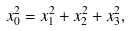<formula> <loc_0><loc_0><loc_500><loc_500>x _ { 0 } ^ { 2 } = x _ { 1 } ^ { 2 } + x _ { 2 } ^ { 2 } + x _ { 3 } ^ { 2 } ,</formula> 